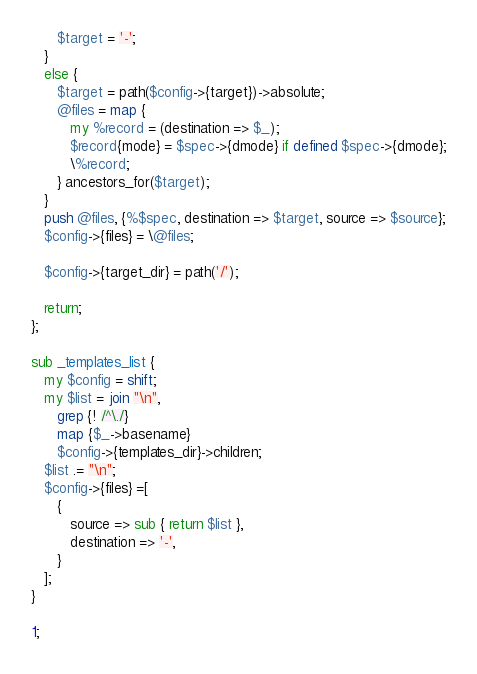<code> <loc_0><loc_0><loc_500><loc_500><_Perl_>      $target = '-';
   }
   else {
      $target = path($config->{target})->absolute;
      @files = map {
         my %record = (destination => $_);
         $record{mode} = $spec->{dmode} if defined $spec->{dmode};
         \%record;
      } ancestors_for($target);
   }
   push @files, {%$spec, destination => $target, source => $source};
   $config->{files} = \@files;

   $config->{target_dir} = path('/');

   return;
};

sub _templates_list {
   my $config = shift;
   my $list = join "\n",
      grep {! /^\./}
      map {$_->basename}
      $config->{templates_dir}->children;
   $list .= "\n";
   $config->{files} =[
      {
         source => sub { return $list },
         destination => '-',
      }
   ];
}

1;
</code> 